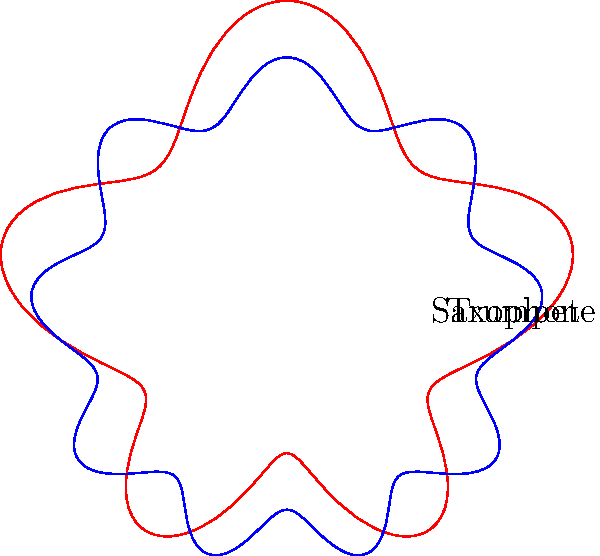In the polar graph shown, two instrument tones are represented: a trumpet (red) and a saxophone (blue). Which instrument's sound wave pattern exhibits more lobes, indicating a more complex harmonic structure? To determine which instrument has a more complex harmonic structure, we need to analyze the number of lobes in each polar graph:

1. Trumpet (red curve):
   - The red curve represents the trumpet's sound wave pattern.
   - Counting the lobes, we can see that it has 6 major lobes.

2. Saxophone (blue curve):
   - The blue curve represents the saxophone's sound wave pattern.
   - Counting the lobes, we can see that it has 10 major lobes.

3. Comparison:
   - More lobes in a polar representation of a sound wave indicate a more complex harmonic structure.
   - The saxophone (blue) has 10 lobes, while the trumpet (red) has 6 lobes.

4. Interpretation:
   - A higher number of lobes suggests that the instrument produces a richer set of overtones or harmonics.
   - This complexity in the harmonic structure contributes to the instrument's unique timbre or tone color.

Therefore, the saxophone's sound wave pattern exhibits more lobes, indicating a more complex harmonic structure compared to the trumpet in this representation.
Answer: Saxophone 